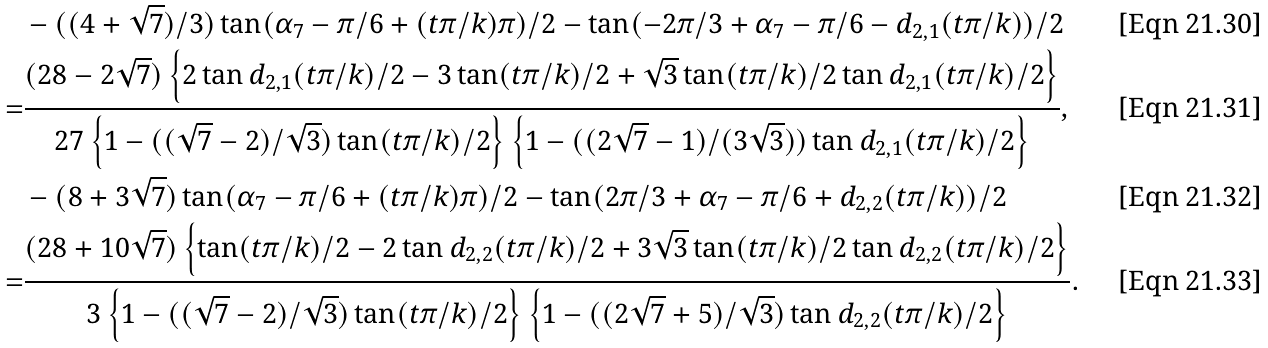<formula> <loc_0><loc_0><loc_500><loc_500>& - ( ( 4 + \sqrt { 7 } ) / 3 ) \tan ( \alpha _ { 7 } - \pi / 6 + ( t \pi / k ) \pi ) / 2 - \tan ( - 2 \pi / 3 + \alpha _ { 7 } - \pi / 6 - d _ { 2 , 1 } ( t \pi / k ) ) / 2 \\ = & \frac { ( 2 8 - 2 \sqrt { 7 } ) \left \{ 2 \tan d _ { 2 , 1 } ( t \pi / k ) / 2 - 3 \tan ( t \pi / k ) / 2 + \sqrt { 3 } \tan ( t \pi / k ) / 2 \tan d _ { 2 , 1 } ( t \pi / k ) / 2 \right \} } { 2 7 \left \{ 1 - ( ( \sqrt { 7 } - 2 ) / \sqrt { 3 } ) \tan ( t \pi / k ) / 2 \right \} \left \{ 1 - ( ( 2 \sqrt { 7 } - 1 ) / ( 3 \sqrt { 3 } ) ) \tan d _ { 2 , 1 } ( t \pi / k ) / 2 \right \} } , \\ & - ( 8 + 3 \sqrt { 7 } ) \tan ( \alpha _ { 7 } - \pi / 6 + ( t \pi / k ) \pi ) / 2 - \tan ( 2 \pi / 3 + \alpha _ { 7 } - \pi / 6 + d _ { 2 , 2 } ( t \pi / k ) ) / 2 \\ = & \frac { ( 2 8 + 1 0 \sqrt { 7 } ) \left \{ \tan ( t \pi / k ) / 2 - 2 \tan d _ { 2 , 2 } ( t \pi / k ) / 2 + 3 \sqrt { 3 } \tan ( t \pi / k ) / 2 \tan d _ { 2 , 2 } ( t \pi / k ) / 2 \right \} } { 3 \left \{ 1 - ( ( \sqrt { 7 } - 2 ) / \sqrt { 3 } ) \tan ( t \pi / k ) / 2 \right \} \left \{ 1 - ( ( 2 \sqrt { 7 } + 5 ) / \sqrt { 3 } ) \tan d _ { 2 , 2 } ( t \pi / k ) / 2 \right \} } .</formula> 